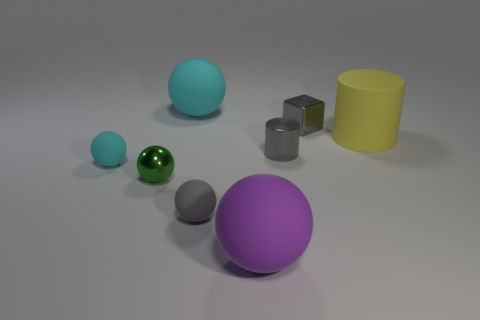There is a tiny metal sphere; is its color the same as the big matte thing that is behind the yellow thing?
Ensure brevity in your answer.  No. How many small green shiny things are there?
Provide a short and direct response. 1. Is there a ball that has the same color as the small cylinder?
Provide a succinct answer. Yes. What color is the small sphere to the left of the tiny shiny thing that is to the left of the big thing that is to the left of the big purple matte thing?
Your response must be concise. Cyan. Is the big purple ball made of the same material as the cylinder left of the yellow object?
Keep it short and to the point. No. What material is the tiny cyan object?
Provide a succinct answer. Rubber. What is the material of the tiny sphere that is the same color as the shiny cylinder?
Ensure brevity in your answer.  Rubber. How many other things are the same material as the purple thing?
Your answer should be very brief. 4. What shape is the small thing that is both to the left of the purple sphere and behind the tiny green metallic thing?
Offer a terse response. Sphere. There is a tiny ball that is made of the same material as the small gray cube; what color is it?
Give a very brief answer. Green. 